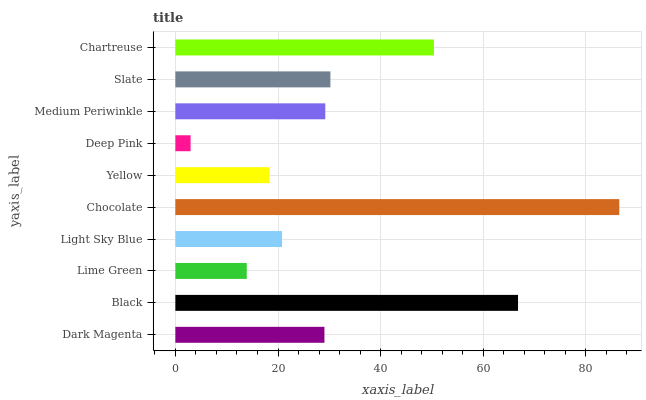Is Deep Pink the minimum?
Answer yes or no. Yes. Is Chocolate the maximum?
Answer yes or no. Yes. Is Black the minimum?
Answer yes or no. No. Is Black the maximum?
Answer yes or no. No. Is Black greater than Dark Magenta?
Answer yes or no. Yes. Is Dark Magenta less than Black?
Answer yes or no. Yes. Is Dark Magenta greater than Black?
Answer yes or no. No. Is Black less than Dark Magenta?
Answer yes or no. No. Is Medium Periwinkle the high median?
Answer yes or no. Yes. Is Dark Magenta the low median?
Answer yes or no. Yes. Is Deep Pink the high median?
Answer yes or no. No. Is Chartreuse the low median?
Answer yes or no. No. 